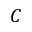Convert formula to latex. <formula><loc_0><loc_0><loc_500><loc_500>C</formula> 